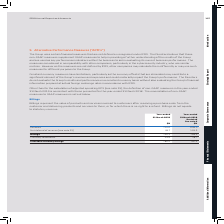According to Sophos Group's financial document, What do Billings represent? the value of products and services invoiced to customers after receiving a purchase order from the customer and delivering products and services to them, or for which there is no right to a refund. Billings do not equate to statutory revenue.. The document states: "Billings represent the value of products and services invoiced to customers after receiving a purchase order from the customer and delivering products..." Also, What was the amount of Billings in 2019? According to the financial document, 760.3 (in millions). The relevant text states: "Billings 760.3 768.6..." Also, What were the components in the table used to calculate Billings? The document shows two values: Revenue and Net deferral of revenue. From the document: "Net deferral of revenue (see note 23) 49.7 129.6 Net deferral of revenue (see note 23) 49.7 129.6..." Additionally, In which year was the amount of Billings larger? According to the financial document, 2018. The relevant text states: "with those presented for the year-ended 31 March 2018. The reconciliation of non-GAAP measures to GAAP measures is set out below...." Also, can you calculate: What was the change in Revenue in 2019 from 2018? Based on the calculation: 710.6-639.0, the result is 71.6 (in millions). This is based on the information: "Revenue 710.6 639.0 Revenue 710.6 639.0..." The key data points involved are: 639.0, 710.6. Also, can you calculate: What was the percentage change in Revenue in 2019 from 2018? To answer this question, I need to perform calculations using the financial data. The calculation is: (710.6-639.0)/639.0, which equals 11.21 (percentage). This is based on the information: "Revenue 710.6 639.0 Revenue 710.6 639.0..." The key data points involved are: 639.0, 710.6. 